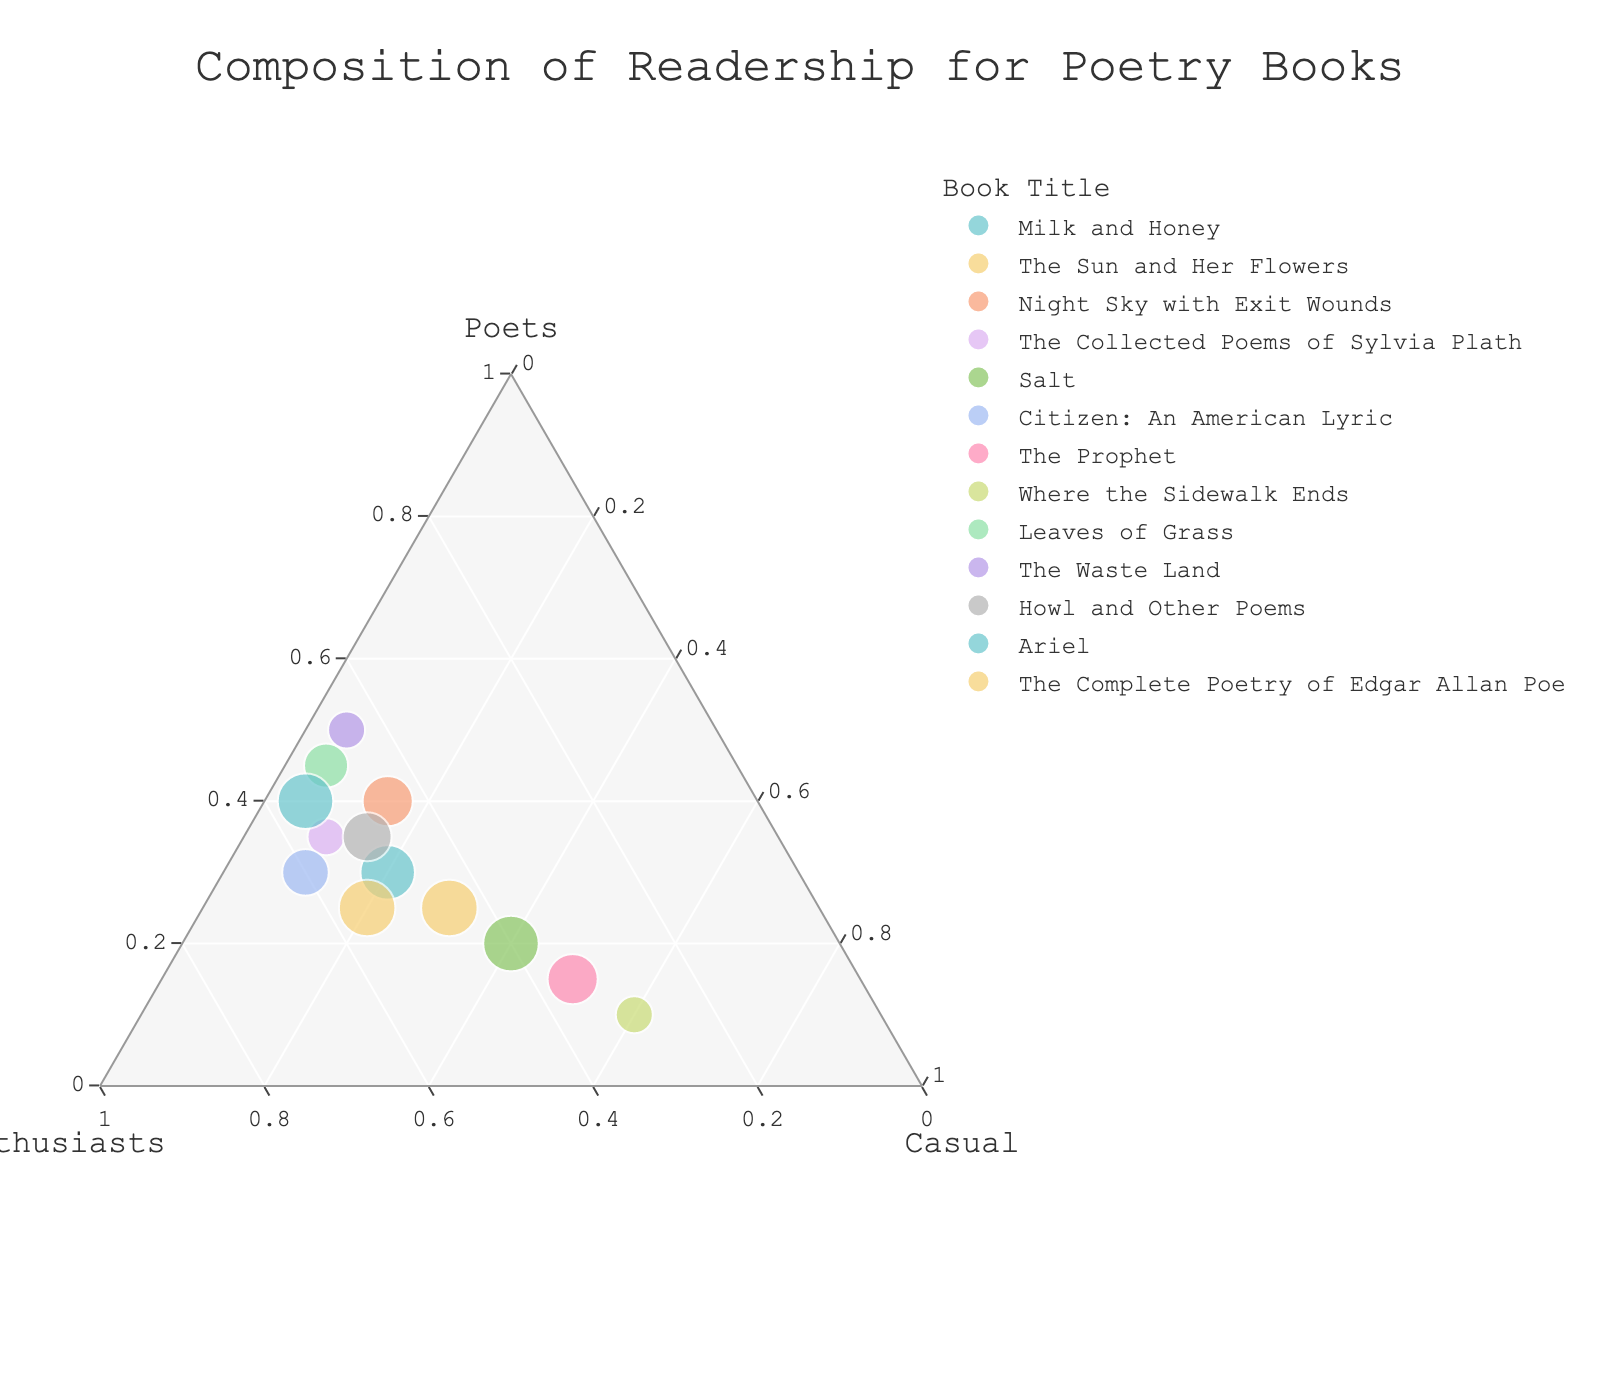How many books are represented in the figure? Count the total number of unique data points plotted on the ternary graph, each representing a different book title.
Answer: 13 Which book has the highest proportion of fellow poets as readers? Locate the point closest to the vertex labeled "Poets". This represents the highest proportion of fellow poets among all books. The title associated with that point is the answer.
Answer: The Waste Land Between "Salt" and "Citizen: An American Lyric," which book has the higher proportion of casual readers? Compare the positions of the two respective points along the axis labeled "Casual." The point closer to the "Casual" vertex represents the book with the higher proportion of casual readers.
Answer: Salt What is the smallest proportion of casual readers recorded among all the books? Identify the data point that is closest to the axis for "Casual Readers" but not on the axis lines. This point represents the smallest percentage of casual readers.
Answer: 5% Is there any book that appeals equally to fellow poets and literature enthusiasts but not to casual readers? Look for data points equidistant between the vertices "Poets" and "Enthusiasts" but shifted away from the "Casual" vertex. Analyze which, if any, meet that criterion.
Answer: No Which poetry book has an almost equal proportion of literature enthusiasts and casual readers? Locate the data point that is approximately equidistant from vertices labeled "Enthusiasts" and "Casual." Check the corresponding book title.
Answer: The Prophet What is the range of proportions for poetry books' appeal to casual readers? Find the highest and lowest points along the "Casual" axis. Subtract the lowest value from the highest value to get the range.
Answer: 55% How many books have more than 40% of their readers as literature enthusiasts? Count the number of data points that are positioned above the 40% tick mark on the "Enthusiasts" axis.
Answer: 9 Which book has the most balanced composition of readership among fellow poets, literature enthusiasts, and casual readers? Search for the data point that is closest to the center of the ternary plot, indicating a balance among the three types of readers.
Answer: Salt Among "Leaves of Grass," "Howl and Other Poems," and "Night Sky with Exit Wounds," which book has the highest proportion of literature enthusiasts? Compare the positions of the three data points along the "Enthusiasts" axis. The point closest to the "Enthusiasts" vertex indicates the book with the highest proportion of literature enthusiasts.
Answer: Leaves of Grass 